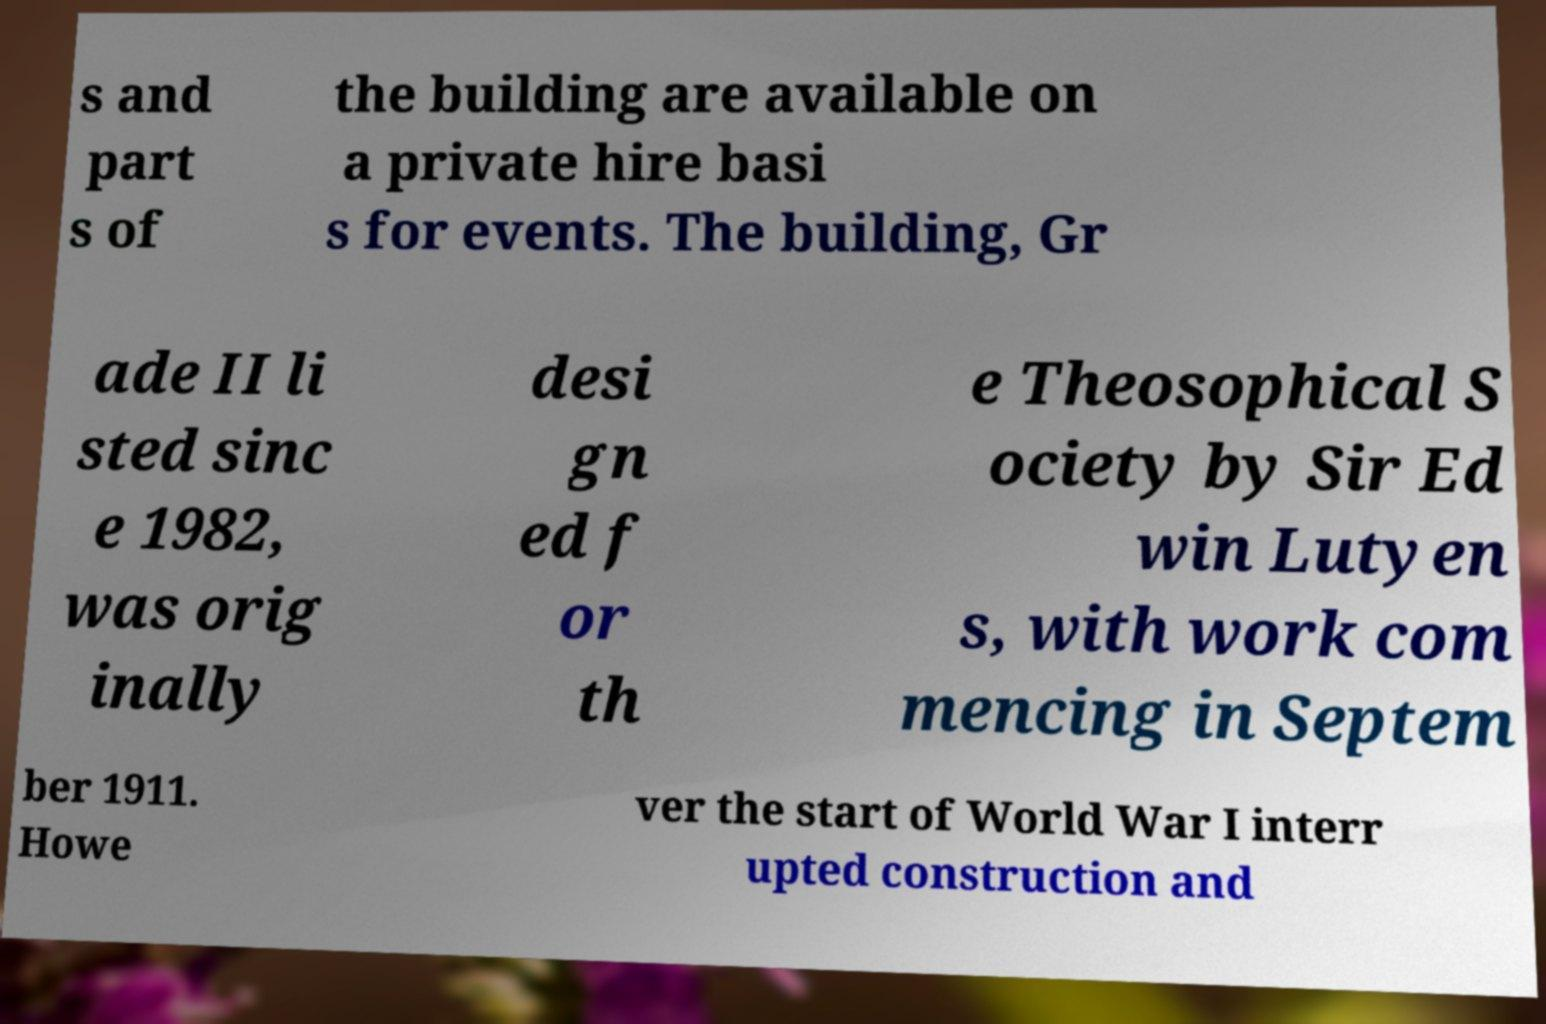Please identify and transcribe the text found in this image. s and part s of the building are available on a private hire basi s for events. The building, Gr ade II li sted sinc e 1982, was orig inally desi gn ed f or th e Theosophical S ociety by Sir Ed win Lutyen s, with work com mencing in Septem ber 1911. Howe ver the start of World War I interr upted construction and 